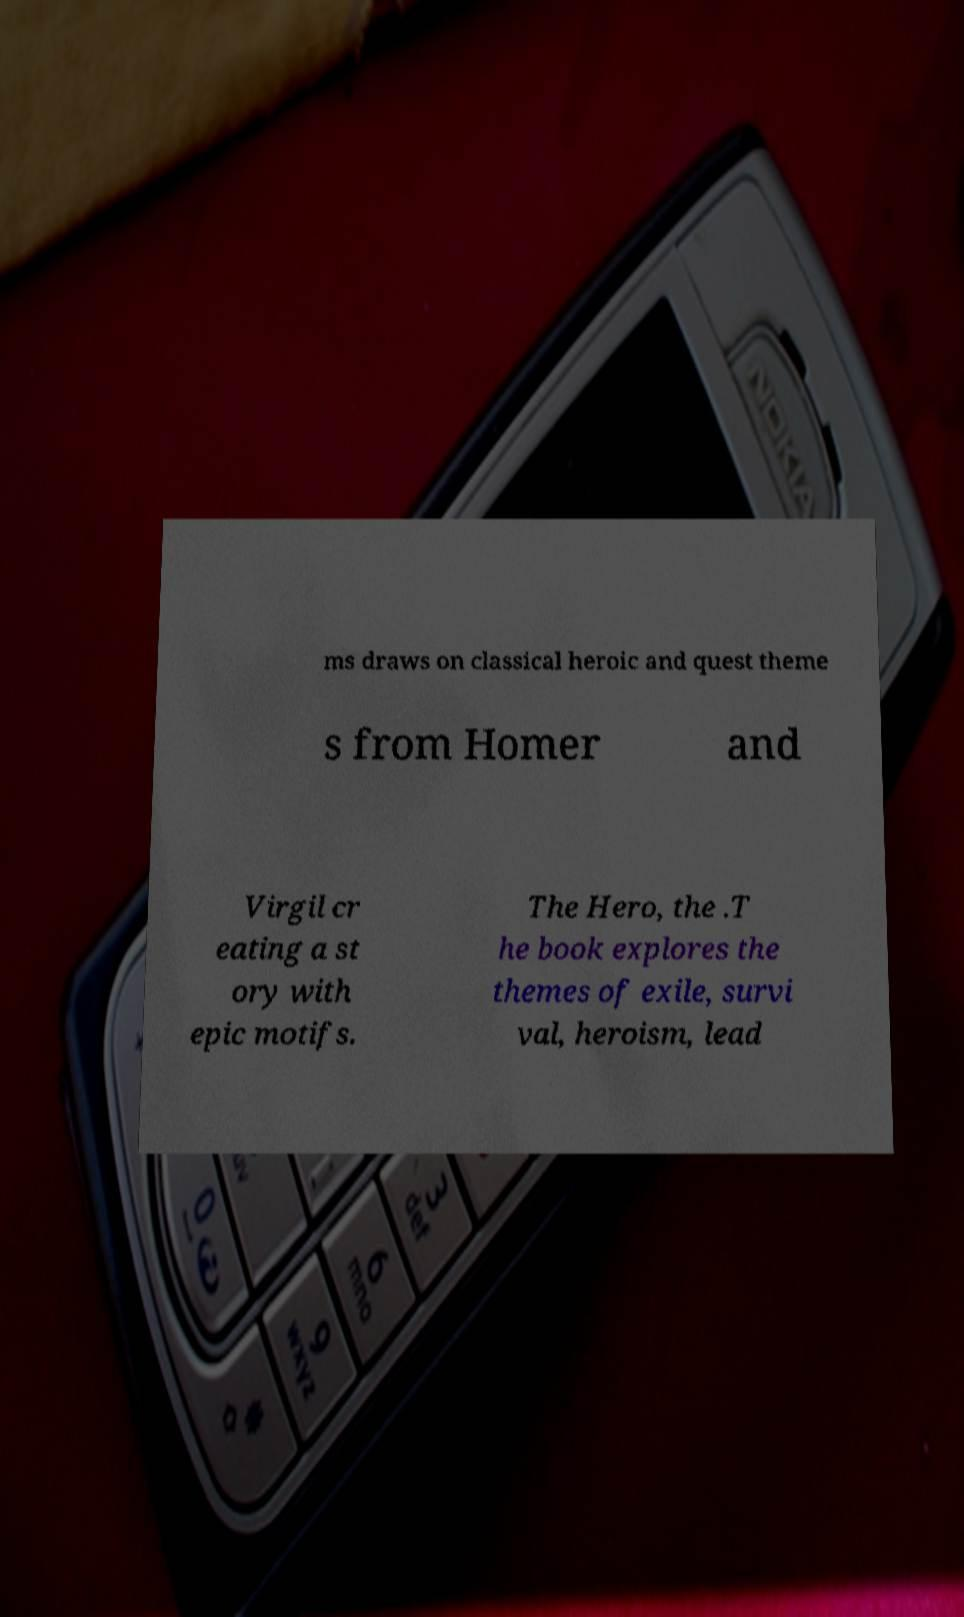Please identify and transcribe the text found in this image. ms draws on classical heroic and quest theme s from Homer and Virgil cr eating a st ory with epic motifs. The Hero, the .T he book explores the themes of exile, survi val, heroism, lead 